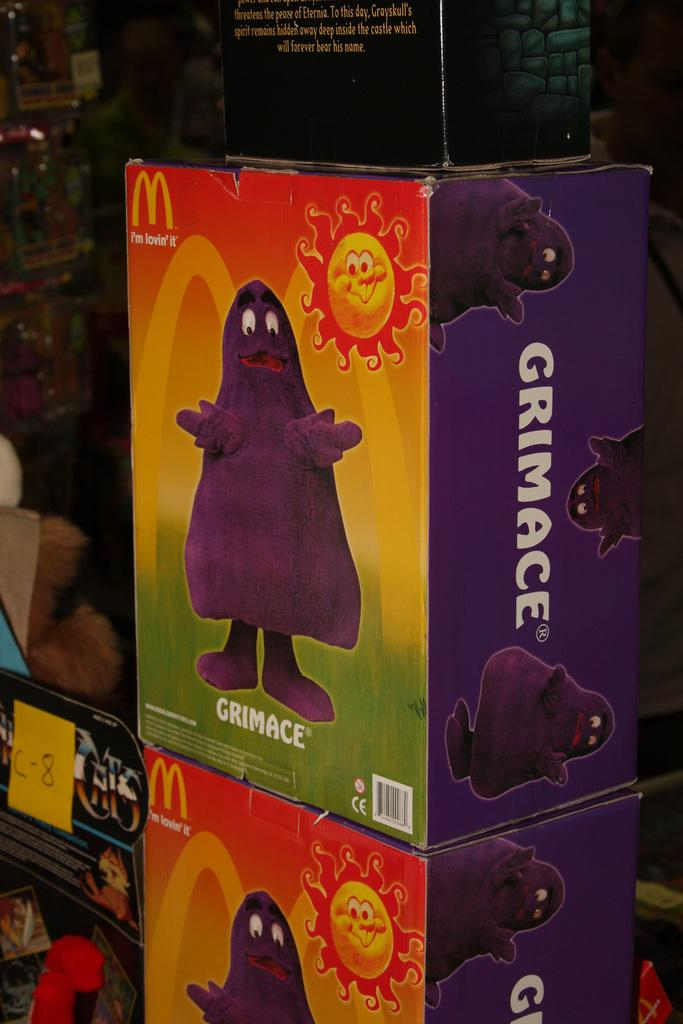What is the main subject of the image? The main subject of the image is many boxes. Are there any specific features on the boxes? Yes, there is an animated picture on one of the boxes, and there is text on one of the boxes. What can be observed about the background of the image? The background of the image is dark. What type of collar can be seen on the animated character in the image? There is no animated character with a collar present in the image. What journey is depicted in the image? There is no journey depicted in the image; it features many boxes with an animated picture and text. 